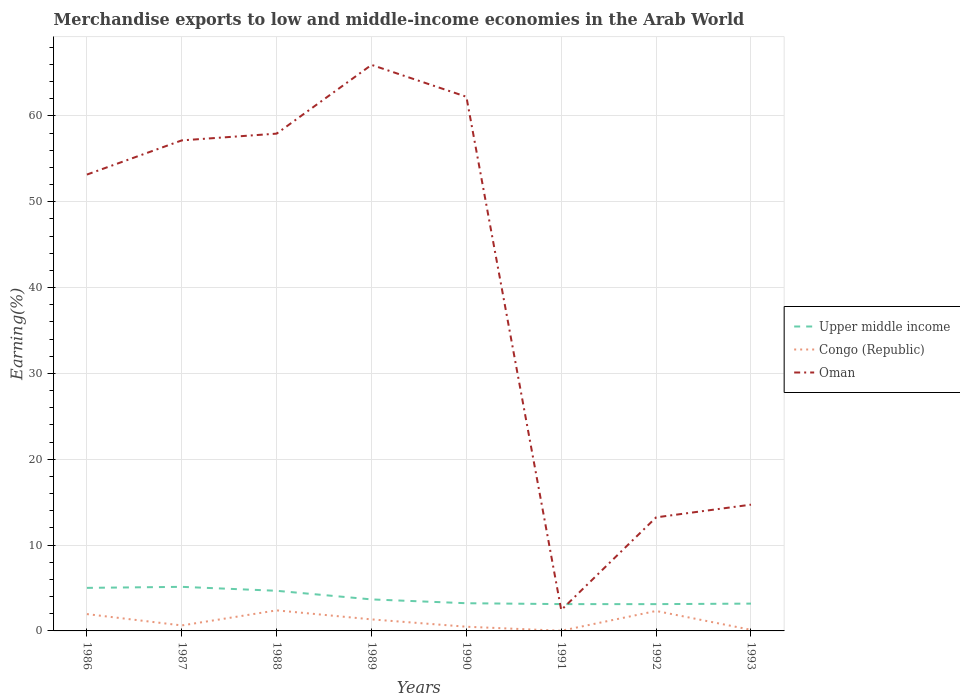How many different coloured lines are there?
Make the answer very short. 3. Is the number of lines equal to the number of legend labels?
Keep it short and to the point. Yes. Across all years, what is the maximum percentage of amount earned from merchandise exports in Oman?
Your answer should be very brief. 2.43. In which year was the percentage of amount earned from merchandise exports in Congo (Republic) maximum?
Your answer should be very brief. 1991. What is the total percentage of amount earned from merchandise exports in Upper middle income in the graph?
Your answer should be compact. 1.95. What is the difference between the highest and the second highest percentage of amount earned from merchandise exports in Upper middle income?
Provide a short and direct response. 2.01. What is the difference between the highest and the lowest percentage of amount earned from merchandise exports in Upper middle income?
Give a very brief answer. 3. Is the percentage of amount earned from merchandise exports in Oman strictly greater than the percentage of amount earned from merchandise exports in Congo (Republic) over the years?
Your response must be concise. No. What is the difference between two consecutive major ticks on the Y-axis?
Your answer should be very brief. 10. Does the graph contain any zero values?
Offer a terse response. No. Where does the legend appear in the graph?
Offer a very short reply. Center right. What is the title of the graph?
Make the answer very short. Merchandise exports to low and middle-income economies in the Arab World. What is the label or title of the X-axis?
Your answer should be compact. Years. What is the label or title of the Y-axis?
Provide a succinct answer. Earning(%). What is the Earning(%) in Upper middle income in 1986?
Offer a terse response. 5.01. What is the Earning(%) in Congo (Republic) in 1986?
Give a very brief answer. 1.96. What is the Earning(%) in Oman in 1986?
Your answer should be very brief. 53.16. What is the Earning(%) in Upper middle income in 1987?
Offer a terse response. 5.13. What is the Earning(%) of Congo (Republic) in 1987?
Offer a very short reply. 0.64. What is the Earning(%) of Oman in 1987?
Make the answer very short. 57.14. What is the Earning(%) of Upper middle income in 1988?
Give a very brief answer. 4.67. What is the Earning(%) of Congo (Republic) in 1988?
Your answer should be very brief. 2.39. What is the Earning(%) in Oman in 1988?
Provide a succinct answer. 57.93. What is the Earning(%) in Upper middle income in 1989?
Give a very brief answer. 3.67. What is the Earning(%) in Congo (Republic) in 1989?
Your response must be concise. 1.34. What is the Earning(%) in Oman in 1989?
Provide a short and direct response. 65.94. What is the Earning(%) in Upper middle income in 1990?
Ensure brevity in your answer.  3.23. What is the Earning(%) of Congo (Republic) in 1990?
Give a very brief answer. 0.49. What is the Earning(%) in Oman in 1990?
Your answer should be compact. 62.22. What is the Earning(%) of Upper middle income in 1991?
Your answer should be very brief. 3.12. What is the Earning(%) in Congo (Republic) in 1991?
Make the answer very short. 0.02. What is the Earning(%) of Oman in 1991?
Offer a very short reply. 2.43. What is the Earning(%) of Upper middle income in 1992?
Your answer should be compact. 3.12. What is the Earning(%) of Congo (Republic) in 1992?
Offer a terse response. 2.32. What is the Earning(%) in Oman in 1992?
Provide a short and direct response. 13.23. What is the Earning(%) of Upper middle income in 1993?
Provide a short and direct response. 3.18. What is the Earning(%) of Congo (Republic) in 1993?
Ensure brevity in your answer.  0.13. What is the Earning(%) of Oman in 1993?
Make the answer very short. 14.71. Across all years, what is the maximum Earning(%) in Upper middle income?
Your response must be concise. 5.13. Across all years, what is the maximum Earning(%) in Congo (Republic)?
Your response must be concise. 2.39. Across all years, what is the maximum Earning(%) of Oman?
Your answer should be very brief. 65.94. Across all years, what is the minimum Earning(%) of Upper middle income?
Your answer should be very brief. 3.12. Across all years, what is the minimum Earning(%) in Congo (Republic)?
Your answer should be compact. 0.02. Across all years, what is the minimum Earning(%) in Oman?
Your answer should be very brief. 2.43. What is the total Earning(%) of Upper middle income in the graph?
Make the answer very short. 31.15. What is the total Earning(%) of Congo (Republic) in the graph?
Your answer should be very brief. 9.3. What is the total Earning(%) in Oman in the graph?
Offer a very short reply. 326.75. What is the difference between the Earning(%) in Upper middle income in 1986 and that in 1987?
Provide a succinct answer. -0.12. What is the difference between the Earning(%) of Congo (Republic) in 1986 and that in 1987?
Ensure brevity in your answer.  1.32. What is the difference between the Earning(%) of Oman in 1986 and that in 1987?
Your response must be concise. -3.98. What is the difference between the Earning(%) in Upper middle income in 1986 and that in 1988?
Ensure brevity in your answer.  0.34. What is the difference between the Earning(%) of Congo (Republic) in 1986 and that in 1988?
Your answer should be very brief. -0.43. What is the difference between the Earning(%) in Oman in 1986 and that in 1988?
Offer a terse response. -4.77. What is the difference between the Earning(%) of Upper middle income in 1986 and that in 1989?
Keep it short and to the point. 1.34. What is the difference between the Earning(%) in Congo (Republic) in 1986 and that in 1989?
Your answer should be very brief. 0.62. What is the difference between the Earning(%) in Oman in 1986 and that in 1989?
Make the answer very short. -12.78. What is the difference between the Earning(%) in Upper middle income in 1986 and that in 1990?
Keep it short and to the point. 1.79. What is the difference between the Earning(%) in Congo (Republic) in 1986 and that in 1990?
Offer a terse response. 1.47. What is the difference between the Earning(%) of Oman in 1986 and that in 1990?
Ensure brevity in your answer.  -9.06. What is the difference between the Earning(%) in Upper middle income in 1986 and that in 1991?
Offer a terse response. 1.89. What is the difference between the Earning(%) of Congo (Republic) in 1986 and that in 1991?
Keep it short and to the point. 1.94. What is the difference between the Earning(%) in Oman in 1986 and that in 1991?
Provide a short and direct response. 50.72. What is the difference between the Earning(%) in Upper middle income in 1986 and that in 1992?
Offer a very short reply. 1.89. What is the difference between the Earning(%) of Congo (Republic) in 1986 and that in 1992?
Give a very brief answer. -0.36. What is the difference between the Earning(%) in Oman in 1986 and that in 1992?
Offer a very short reply. 39.93. What is the difference between the Earning(%) of Upper middle income in 1986 and that in 1993?
Give a very brief answer. 1.83. What is the difference between the Earning(%) of Congo (Republic) in 1986 and that in 1993?
Give a very brief answer. 1.83. What is the difference between the Earning(%) of Oman in 1986 and that in 1993?
Offer a very short reply. 38.45. What is the difference between the Earning(%) of Upper middle income in 1987 and that in 1988?
Offer a very short reply. 0.46. What is the difference between the Earning(%) in Congo (Republic) in 1987 and that in 1988?
Keep it short and to the point. -1.76. What is the difference between the Earning(%) in Oman in 1987 and that in 1988?
Offer a terse response. -0.79. What is the difference between the Earning(%) in Upper middle income in 1987 and that in 1989?
Provide a short and direct response. 1.46. What is the difference between the Earning(%) of Congo (Republic) in 1987 and that in 1989?
Offer a terse response. -0.7. What is the difference between the Earning(%) of Oman in 1987 and that in 1989?
Offer a terse response. -8.8. What is the difference between the Earning(%) in Upper middle income in 1987 and that in 1990?
Make the answer very short. 1.91. What is the difference between the Earning(%) in Congo (Republic) in 1987 and that in 1990?
Keep it short and to the point. 0.15. What is the difference between the Earning(%) of Oman in 1987 and that in 1990?
Your answer should be very brief. -5.08. What is the difference between the Earning(%) in Upper middle income in 1987 and that in 1991?
Your response must be concise. 2.01. What is the difference between the Earning(%) in Congo (Republic) in 1987 and that in 1991?
Your answer should be compact. 0.62. What is the difference between the Earning(%) of Oman in 1987 and that in 1991?
Give a very brief answer. 54.71. What is the difference between the Earning(%) of Upper middle income in 1987 and that in 1992?
Offer a very short reply. 2.01. What is the difference between the Earning(%) of Congo (Republic) in 1987 and that in 1992?
Provide a succinct answer. -1.69. What is the difference between the Earning(%) in Oman in 1987 and that in 1992?
Keep it short and to the point. 43.91. What is the difference between the Earning(%) of Upper middle income in 1987 and that in 1993?
Give a very brief answer. 1.95. What is the difference between the Earning(%) in Congo (Republic) in 1987 and that in 1993?
Ensure brevity in your answer.  0.51. What is the difference between the Earning(%) of Oman in 1987 and that in 1993?
Keep it short and to the point. 42.43. What is the difference between the Earning(%) of Upper middle income in 1988 and that in 1989?
Provide a short and direct response. 1. What is the difference between the Earning(%) in Congo (Republic) in 1988 and that in 1989?
Keep it short and to the point. 1.05. What is the difference between the Earning(%) in Oman in 1988 and that in 1989?
Your response must be concise. -8.01. What is the difference between the Earning(%) in Upper middle income in 1988 and that in 1990?
Give a very brief answer. 1.45. What is the difference between the Earning(%) in Congo (Republic) in 1988 and that in 1990?
Your answer should be compact. 1.91. What is the difference between the Earning(%) of Oman in 1988 and that in 1990?
Your answer should be compact. -4.29. What is the difference between the Earning(%) in Upper middle income in 1988 and that in 1991?
Offer a terse response. 1.55. What is the difference between the Earning(%) of Congo (Republic) in 1988 and that in 1991?
Provide a succinct answer. 2.38. What is the difference between the Earning(%) of Oman in 1988 and that in 1991?
Keep it short and to the point. 55.49. What is the difference between the Earning(%) of Upper middle income in 1988 and that in 1992?
Ensure brevity in your answer.  1.55. What is the difference between the Earning(%) of Congo (Republic) in 1988 and that in 1992?
Provide a short and direct response. 0.07. What is the difference between the Earning(%) in Oman in 1988 and that in 1992?
Make the answer very short. 44.7. What is the difference between the Earning(%) in Upper middle income in 1988 and that in 1993?
Your response must be concise. 1.49. What is the difference between the Earning(%) in Congo (Republic) in 1988 and that in 1993?
Provide a succinct answer. 2.27. What is the difference between the Earning(%) of Oman in 1988 and that in 1993?
Your answer should be compact. 43.22. What is the difference between the Earning(%) in Upper middle income in 1989 and that in 1990?
Provide a succinct answer. 0.45. What is the difference between the Earning(%) of Congo (Republic) in 1989 and that in 1990?
Offer a very short reply. 0.85. What is the difference between the Earning(%) of Oman in 1989 and that in 1990?
Provide a short and direct response. 3.71. What is the difference between the Earning(%) of Upper middle income in 1989 and that in 1991?
Your response must be concise. 0.55. What is the difference between the Earning(%) in Congo (Republic) in 1989 and that in 1991?
Give a very brief answer. 1.32. What is the difference between the Earning(%) in Oman in 1989 and that in 1991?
Keep it short and to the point. 63.5. What is the difference between the Earning(%) of Upper middle income in 1989 and that in 1992?
Offer a terse response. 0.55. What is the difference between the Earning(%) of Congo (Republic) in 1989 and that in 1992?
Your answer should be compact. -0.98. What is the difference between the Earning(%) of Oman in 1989 and that in 1992?
Your answer should be very brief. 52.71. What is the difference between the Earning(%) in Upper middle income in 1989 and that in 1993?
Your response must be concise. 0.49. What is the difference between the Earning(%) of Congo (Republic) in 1989 and that in 1993?
Offer a terse response. 1.22. What is the difference between the Earning(%) in Oman in 1989 and that in 1993?
Keep it short and to the point. 51.23. What is the difference between the Earning(%) in Upper middle income in 1990 and that in 1991?
Your answer should be very brief. 0.1. What is the difference between the Earning(%) of Congo (Republic) in 1990 and that in 1991?
Offer a very short reply. 0.47. What is the difference between the Earning(%) of Oman in 1990 and that in 1991?
Keep it short and to the point. 59.79. What is the difference between the Earning(%) of Upper middle income in 1990 and that in 1992?
Your answer should be compact. 0.11. What is the difference between the Earning(%) in Congo (Republic) in 1990 and that in 1992?
Offer a terse response. -1.84. What is the difference between the Earning(%) in Oman in 1990 and that in 1992?
Your response must be concise. 49. What is the difference between the Earning(%) of Upper middle income in 1990 and that in 1993?
Ensure brevity in your answer.  0.05. What is the difference between the Earning(%) of Congo (Republic) in 1990 and that in 1993?
Offer a very short reply. 0.36. What is the difference between the Earning(%) of Oman in 1990 and that in 1993?
Give a very brief answer. 47.51. What is the difference between the Earning(%) of Upper middle income in 1991 and that in 1992?
Your answer should be compact. 0. What is the difference between the Earning(%) in Congo (Republic) in 1991 and that in 1992?
Give a very brief answer. -2.31. What is the difference between the Earning(%) in Oman in 1991 and that in 1992?
Your answer should be compact. -10.79. What is the difference between the Earning(%) in Upper middle income in 1991 and that in 1993?
Your answer should be compact. -0.06. What is the difference between the Earning(%) of Congo (Republic) in 1991 and that in 1993?
Your response must be concise. -0.11. What is the difference between the Earning(%) in Oman in 1991 and that in 1993?
Provide a succinct answer. -12.27. What is the difference between the Earning(%) in Upper middle income in 1992 and that in 1993?
Offer a terse response. -0.06. What is the difference between the Earning(%) in Congo (Republic) in 1992 and that in 1993?
Ensure brevity in your answer.  2.2. What is the difference between the Earning(%) of Oman in 1992 and that in 1993?
Offer a very short reply. -1.48. What is the difference between the Earning(%) in Upper middle income in 1986 and the Earning(%) in Congo (Republic) in 1987?
Ensure brevity in your answer.  4.38. What is the difference between the Earning(%) in Upper middle income in 1986 and the Earning(%) in Oman in 1987?
Offer a very short reply. -52.13. What is the difference between the Earning(%) in Congo (Republic) in 1986 and the Earning(%) in Oman in 1987?
Give a very brief answer. -55.18. What is the difference between the Earning(%) of Upper middle income in 1986 and the Earning(%) of Congo (Republic) in 1988?
Ensure brevity in your answer.  2.62. What is the difference between the Earning(%) of Upper middle income in 1986 and the Earning(%) of Oman in 1988?
Give a very brief answer. -52.91. What is the difference between the Earning(%) in Congo (Republic) in 1986 and the Earning(%) in Oman in 1988?
Your answer should be very brief. -55.97. What is the difference between the Earning(%) in Upper middle income in 1986 and the Earning(%) in Congo (Republic) in 1989?
Provide a succinct answer. 3.67. What is the difference between the Earning(%) in Upper middle income in 1986 and the Earning(%) in Oman in 1989?
Your response must be concise. -60.92. What is the difference between the Earning(%) of Congo (Republic) in 1986 and the Earning(%) of Oman in 1989?
Offer a very short reply. -63.98. What is the difference between the Earning(%) of Upper middle income in 1986 and the Earning(%) of Congo (Republic) in 1990?
Offer a terse response. 4.53. What is the difference between the Earning(%) of Upper middle income in 1986 and the Earning(%) of Oman in 1990?
Provide a short and direct response. -57.21. What is the difference between the Earning(%) in Congo (Republic) in 1986 and the Earning(%) in Oman in 1990?
Your answer should be very brief. -60.26. What is the difference between the Earning(%) in Upper middle income in 1986 and the Earning(%) in Congo (Republic) in 1991?
Give a very brief answer. 5. What is the difference between the Earning(%) of Upper middle income in 1986 and the Earning(%) of Oman in 1991?
Make the answer very short. 2.58. What is the difference between the Earning(%) of Congo (Republic) in 1986 and the Earning(%) of Oman in 1991?
Give a very brief answer. -0.47. What is the difference between the Earning(%) of Upper middle income in 1986 and the Earning(%) of Congo (Republic) in 1992?
Give a very brief answer. 2.69. What is the difference between the Earning(%) of Upper middle income in 1986 and the Earning(%) of Oman in 1992?
Your response must be concise. -8.21. What is the difference between the Earning(%) of Congo (Republic) in 1986 and the Earning(%) of Oman in 1992?
Offer a terse response. -11.27. What is the difference between the Earning(%) of Upper middle income in 1986 and the Earning(%) of Congo (Republic) in 1993?
Provide a short and direct response. 4.89. What is the difference between the Earning(%) of Upper middle income in 1986 and the Earning(%) of Oman in 1993?
Your answer should be very brief. -9.69. What is the difference between the Earning(%) in Congo (Republic) in 1986 and the Earning(%) in Oman in 1993?
Give a very brief answer. -12.75. What is the difference between the Earning(%) in Upper middle income in 1987 and the Earning(%) in Congo (Republic) in 1988?
Give a very brief answer. 2.74. What is the difference between the Earning(%) of Upper middle income in 1987 and the Earning(%) of Oman in 1988?
Your answer should be very brief. -52.79. What is the difference between the Earning(%) of Congo (Republic) in 1987 and the Earning(%) of Oman in 1988?
Keep it short and to the point. -57.29. What is the difference between the Earning(%) of Upper middle income in 1987 and the Earning(%) of Congo (Republic) in 1989?
Give a very brief answer. 3.79. What is the difference between the Earning(%) in Upper middle income in 1987 and the Earning(%) in Oman in 1989?
Provide a short and direct response. -60.8. What is the difference between the Earning(%) of Congo (Republic) in 1987 and the Earning(%) of Oman in 1989?
Keep it short and to the point. -65.3. What is the difference between the Earning(%) of Upper middle income in 1987 and the Earning(%) of Congo (Republic) in 1990?
Provide a short and direct response. 4.65. What is the difference between the Earning(%) of Upper middle income in 1987 and the Earning(%) of Oman in 1990?
Your answer should be compact. -57.09. What is the difference between the Earning(%) of Congo (Republic) in 1987 and the Earning(%) of Oman in 1990?
Your answer should be compact. -61.58. What is the difference between the Earning(%) in Upper middle income in 1987 and the Earning(%) in Congo (Republic) in 1991?
Offer a terse response. 5.12. What is the difference between the Earning(%) in Upper middle income in 1987 and the Earning(%) in Oman in 1991?
Give a very brief answer. 2.7. What is the difference between the Earning(%) in Congo (Republic) in 1987 and the Earning(%) in Oman in 1991?
Your answer should be compact. -1.79. What is the difference between the Earning(%) in Upper middle income in 1987 and the Earning(%) in Congo (Republic) in 1992?
Ensure brevity in your answer.  2.81. What is the difference between the Earning(%) in Upper middle income in 1987 and the Earning(%) in Oman in 1992?
Your answer should be very brief. -8.09. What is the difference between the Earning(%) of Congo (Republic) in 1987 and the Earning(%) of Oman in 1992?
Offer a very short reply. -12.59. What is the difference between the Earning(%) of Upper middle income in 1987 and the Earning(%) of Congo (Republic) in 1993?
Give a very brief answer. 5.01. What is the difference between the Earning(%) of Upper middle income in 1987 and the Earning(%) of Oman in 1993?
Your response must be concise. -9.57. What is the difference between the Earning(%) of Congo (Republic) in 1987 and the Earning(%) of Oman in 1993?
Provide a short and direct response. -14.07. What is the difference between the Earning(%) of Upper middle income in 1988 and the Earning(%) of Congo (Republic) in 1989?
Offer a terse response. 3.33. What is the difference between the Earning(%) of Upper middle income in 1988 and the Earning(%) of Oman in 1989?
Your answer should be compact. -61.26. What is the difference between the Earning(%) of Congo (Republic) in 1988 and the Earning(%) of Oman in 1989?
Provide a short and direct response. -63.54. What is the difference between the Earning(%) in Upper middle income in 1988 and the Earning(%) in Congo (Republic) in 1990?
Offer a very short reply. 4.19. What is the difference between the Earning(%) in Upper middle income in 1988 and the Earning(%) in Oman in 1990?
Your answer should be compact. -57.55. What is the difference between the Earning(%) in Congo (Republic) in 1988 and the Earning(%) in Oman in 1990?
Your answer should be very brief. -59.83. What is the difference between the Earning(%) in Upper middle income in 1988 and the Earning(%) in Congo (Republic) in 1991?
Provide a succinct answer. 4.66. What is the difference between the Earning(%) of Upper middle income in 1988 and the Earning(%) of Oman in 1991?
Keep it short and to the point. 2.24. What is the difference between the Earning(%) of Congo (Republic) in 1988 and the Earning(%) of Oman in 1991?
Provide a succinct answer. -0.04. What is the difference between the Earning(%) in Upper middle income in 1988 and the Earning(%) in Congo (Republic) in 1992?
Your response must be concise. 2.35. What is the difference between the Earning(%) of Upper middle income in 1988 and the Earning(%) of Oman in 1992?
Give a very brief answer. -8.55. What is the difference between the Earning(%) in Congo (Republic) in 1988 and the Earning(%) in Oman in 1992?
Make the answer very short. -10.83. What is the difference between the Earning(%) of Upper middle income in 1988 and the Earning(%) of Congo (Republic) in 1993?
Give a very brief answer. 4.55. What is the difference between the Earning(%) of Upper middle income in 1988 and the Earning(%) of Oman in 1993?
Your answer should be very brief. -10.03. What is the difference between the Earning(%) of Congo (Republic) in 1988 and the Earning(%) of Oman in 1993?
Offer a terse response. -12.31. What is the difference between the Earning(%) of Upper middle income in 1989 and the Earning(%) of Congo (Republic) in 1990?
Offer a terse response. 3.18. What is the difference between the Earning(%) in Upper middle income in 1989 and the Earning(%) in Oman in 1990?
Keep it short and to the point. -58.55. What is the difference between the Earning(%) of Congo (Republic) in 1989 and the Earning(%) of Oman in 1990?
Your response must be concise. -60.88. What is the difference between the Earning(%) of Upper middle income in 1989 and the Earning(%) of Congo (Republic) in 1991?
Your answer should be very brief. 3.65. What is the difference between the Earning(%) of Upper middle income in 1989 and the Earning(%) of Oman in 1991?
Provide a succinct answer. 1.24. What is the difference between the Earning(%) in Congo (Republic) in 1989 and the Earning(%) in Oman in 1991?
Offer a very short reply. -1.09. What is the difference between the Earning(%) in Upper middle income in 1989 and the Earning(%) in Congo (Republic) in 1992?
Give a very brief answer. 1.35. What is the difference between the Earning(%) in Upper middle income in 1989 and the Earning(%) in Oman in 1992?
Your answer should be very brief. -9.56. What is the difference between the Earning(%) of Congo (Republic) in 1989 and the Earning(%) of Oman in 1992?
Your response must be concise. -11.88. What is the difference between the Earning(%) of Upper middle income in 1989 and the Earning(%) of Congo (Republic) in 1993?
Keep it short and to the point. 3.54. What is the difference between the Earning(%) of Upper middle income in 1989 and the Earning(%) of Oman in 1993?
Provide a succinct answer. -11.04. What is the difference between the Earning(%) of Congo (Republic) in 1989 and the Earning(%) of Oman in 1993?
Make the answer very short. -13.36. What is the difference between the Earning(%) in Upper middle income in 1990 and the Earning(%) in Congo (Republic) in 1991?
Make the answer very short. 3.21. What is the difference between the Earning(%) of Upper middle income in 1990 and the Earning(%) of Oman in 1991?
Your response must be concise. 0.79. What is the difference between the Earning(%) in Congo (Republic) in 1990 and the Earning(%) in Oman in 1991?
Your response must be concise. -1.94. What is the difference between the Earning(%) in Upper middle income in 1990 and the Earning(%) in Congo (Republic) in 1992?
Keep it short and to the point. 0.9. What is the difference between the Earning(%) of Upper middle income in 1990 and the Earning(%) of Oman in 1992?
Give a very brief answer. -10. What is the difference between the Earning(%) in Congo (Republic) in 1990 and the Earning(%) in Oman in 1992?
Ensure brevity in your answer.  -12.74. What is the difference between the Earning(%) of Upper middle income in 1990 and the Earning(%) of Congo (Republic) in 1993?
Your response must be concise. 3.1. What is the difference between the Earning(%) of Upper middle income in 1990 and the Earning(%) of Oman in 1993?
Make the answer very short. -11.48. What is the difference between the Earning(%) of Congo (Republic) in 1990 and the Earning(%) of Oman in 1993?
Keep it short and to the point. -14.22. What is the difference between the Earning(%) of Upper middle income in 1991 and the Earning(%) of Congo (Republic) in 1992?
Provide a succinct answer. 0.8. What is the difference between the Earning(%) in Upper middle income in 1991 and the Earning(%) in Oman in 1992?
Your response must be concise. -10.1. What is the difference between the Earning(%) in Congo (Republic) in 1991 and the Earning(%) in Oman in 1992?
Offer a terse response. -13.21. What is the difference between the Earning(%) in Upper middle income in 1991 and the Earning(%) in Congo (Republic) in 1993?
Make the answer very short. 3. What is the difference between the Earning(%) of Upper middle income in 1991 and the Earning(%) of Oman in 1993?
Give a very brief answer. -11.58. What is the difference between the Earning(%) of Congo (Republic) in 1991 and the Earning(%) of Oman in 1993?
Your response must be concise. -14.69. What is the difference between the Earning(%) of Upper middle income in 1992 and the Earning(%) of Congo (Republic) in 1993?
Provide a succinct answer. 2.99. What is the difference between the Earning(%) of Upper middle income in 1992 and the Earning(%) of Oman in 1993?
Offer a very short reply. -11.59. What is the difference between the Earning(%) in Congo (Republic) in 1992 and the Earning(%) in Oman in 1993?
Provide a short and direct response. -12.38. What is the average Earning(%) in Upper middle income per year?
Your answer should be very brief. 3.89. What is the average Earning(%) in Congo (Republic) per year?
Give a very brief answer. 1.16. What is the average Earning(%) of Oman per year?
Ensure brevity in your answer.  40.84. In the year 1986, what is the difference between the Earning(%) in Upper middle income and Earning(%) in Congo (Republic)?
Give a very brief answer. 3.05. In the year 1986, what is the difference between the Earning(%) of Upper middle income and Earning(%) of Oman?
Your answer should be compact. -48.14. In the year 1986, what is the difference between the Earning(%) of Congo (Republic) and Earning(%) of Oman?
Give a very brief answer. -51.2. In the year 1987, what is the difference between the Earning(%) of Upper middle income and Earning(%) of Congo (Republic)?
Your answer should be very brief. 4.5. In the year 1987, what is the difference between the Earning(%) in Upper middle income and Earning(%) in Oman?
Give a very brief answer. -52.01. In the year 1987, what is the difference between the Earning(%) of Congo (Republic) and Earning(%) of Oman?
Provide a succinct answer. -56.5. In the year 1988, what is the difference between the Earning(%) in Upper middle income and Earning(%) in Congo (Republic)?
Your answer should be very brief. 2.28. In the year 1988, what is the difference between the Earning(%) in Upper middle income and Earning(%) in Oman?
Offer a terse response. -53.25. In the year 1988, what is the difference between the Earning(%) of Congo (Republic) and Earning(%) of Oman?
Your answer should be very brief. -55.53. In the year 1989, what is the difference between the Earning(%) of Upper middle income and Earning(%) of Congo (Republic)?
Make the answer very short. 2.33. In the year 1989, what is the difference between the Earning(%) of Upper middle income and Earning(%) of Oman?
Make the answer very short. -62.27. In the year 1989, what is the difference between the Earning(%) of Congo (Republic) and Earning(%) of Oman?
Offer a very short reply. -64.59. In the year 1990, what is the difference between the Earning(%) of Upper middle income and Earning(%) of Congo (Republic)?
Your answer should be compact. 2.74. In the year 1990, what is the difference between the Earning(%) of Upper middle income and Earning(%) of Oman?
Provide a succinct answer. -59. In the year 1990, what is the difference between the Earning(%) of Congo (Republic) and Earning(%) of Oman?
Offer a very short reply. -61.73. In the year 1991, what is the difference between the Earning(%) in Upper middle income and Earning(%) in Congo (Republic)?
Ensure brevity in your answer.  3.1. In the year 1991, what is the difference between the Earning(%) in Upper middle income and Earning(%) in Oman?
Keep it short and to the point. 0.69. In the year 1991, what is the difference between the Earning(%) of Congo (Republic) and Earning(%) of Oman?
Offer a very short reply. -2.41. In the year 1992, what is the difference between the Earning(%) in Upper middle income and Earning(%) in Congo (Republic)?
Your answer should be compact. 0.8. In the year 1992, what is the difference between the Earning(%) in Upper middle income and Earning(%) in Oman?
Make the answer very short. -10.11. In the year 1992, what is the difference between the Earning(%) in Congo (Republic) and Earning(%) in Oman?
Offer a terse response. -10.9. In the year 1993, what is the difference between the Earning(%) in Upper middle income and Earning(%) in Congo (Republic)?
Offer a very short reply. 3.05. In the year 1993, what is the difference between the Earning(%) in Upper middle income and Earning(%) in Oman?
Offer a terse response. -11.53. In the year 1993, what is the difference between the Earning(%) of Congo (Republic) and Earning(%) of Oman?
Your response must be concise. -14.58. What is the ratio of the Earning(%) of Upper middle income in 1986 to that in 1987?
Your answer should be compact. 0.98. What is the ratio of the Earning(%) in Congo (Republic) in 1986 to that in 1987?
Ensure brevity in your answer.  3.07. What is the ratio of the Earning(%) of Oman in 1986 to that in 1987?
Give a very brief answer. 0.93. What is the ratio of the Earning(%) in Upper middle income in 1986 to that in 1988?
Provide a succinct answer. 1.07. What is the ratio of the Earning(%) in Congo (Republic) in 1986 to that in 1988?
Offer a very short reply. 0.82. What is the ratio of the Earning(%) in Oman in 1986 to that in 1988?
Your answer should be compact. 0.92. What is the ratio of the Earning(%) of Upper middle income in 1986 to that in 1989?
Offer a terse response. 1.37. What is the ratio of the Earning(%) of Congo (Republic) in 1986 to that in 1989?
Ensure brevity in your answer.  1.46. What is the ratio of the Earning(%) of Oman in 1986 to that in 1989?
Offer a terse response. 0.81. What is the ratio of the Earning(%) of Upper middle income in 1986 to that in 1990?
Ensure brevity in your answer.  1.55. What is the ratio of the Earning(%) of Congo (Republic) in 1986 to that in 1990?
Your answer should be compact. 4.01. What is the ratio of the Earning(%) in Oman in 1986 to that in 1990?
Give a very brief answer. 0.85. What is the ratio of the Earning(%) in Upper middle income in 1986 to that in 1991?
Your response must be concise. 1.61. What is the ratio of the Earning(%) of Congo (Republic) in 1986 to that in 1991?
Ensure brevity in your answer.  102.05. What is the ratio of the Earning(%) of Oman in 1986 to that in 1991?
Offer a very short reply. 21.84. What is the ratio of the Earning(%) of Upper middle income in 1986 to that in 1992?
Offer a very short reply. 1.61. What is the ratio of the Earning(%) in Congo (Republic) in 1986 to that in 1992?
Make the answer very short. 0.84. What is the ratio of the Earning(%) of Oman in 1986 to that in 1992?
Keep it short and to the point. 4.02. What is the ratio of the Earning(%) in Upper middle income in 1986 to that in 1993?
Keep it short and to the point. 1.58. What is the ratio of the Earning(%) in Congo (Republic) in 1986 to that in 1993?
Your answer should be very brief. 15.24. What is the ratio of the Earning(%) of Oman in 1986 to that in 1993?
Provide a succinct answer. 3.61. What is the ratio of the Earning(%) of Upper middle income in 1987 to that in 1988?
Provide a short and direct response. 1.1. What is the ratio of the Earning(%) in Congo (Republic) in 1987 to that in 1988?
Offer a very short reply. 0.27. What is the ratio of the Earning(%) of Oman in 1987 to that in 1988?
Offer a very short reply. 0.99. What is the ratio of the Earning(%) of Upper middle income in 1987 to that in 1989?
Your response must be concise. 1.4. What is the ratio of the Earning(%) of Congo (Republic) in 1987 to that in 1989?
Give a very brief answer. 0.48. What is the ratio of the Earning(%) of Oman in 1987 to that in 1989?
Provide a succinct answer. 0.87. What is the ratio of the Earning(%) of Upper middle income in 1987 to that in 1990?
Offer a very short reply. 1.59. What is the ratio of the Earning(%) of Congo (Republic) in 1987 to that in 1990?
Give a very brief answer. 1.31. What is the ratio of the Earning(%) in Oman in 1987 to that in 1990?
Make the answer very short. 0.92. What is the ratio of the Earning(%) in Upper middle income in 1987 to that in 1991?
Keep it short and to the point. 1.64. What is the ratio of the Earning(%) of Congo (Republic) in 1987 to that in 1991?
Offer a very short reply. 33.28. What is the ratio of the Earning(%) in Oman in 1987 to that in 1991?
Ensure brevity in your answer.  23.48. What is the ratio of the Earning(%) in Upper middle income in 1987 to that in 1992?
Offer a terse response. 1.65. What is the ratio of the Earning(%) of Congo (Republic) in 1987 to that in 1992?
Provide a short and direct response. 0.28. What is the ratio of the Earning(%) of Oman in 1987 to that in 1992?
Provide a succinct answer. 4.32. What is the ratio of the Earning(%) in Upper middle income in 1987 to that in 1993?
Make the answer very short. 1.61. What is the ratio of the Earning(%) of Congo (Republic) in 1987 to that in 1993?
Provide a short and direct response. 4.97. What is the ratio of the Earning(%) in Oman in 1987 to that in 1993?
Provide a short and direct response. 3.88. What is the ratio of the Earning(%) of Upper middle income in 1988 to that in 1989?
Offer a very short reply. 1.27. What is the ratio of the Earning(%) of Congo (Republic) in 1988 to that in 1989?
Keep it short and to the point. 1.78. What is the ratio of the Earning(%) of Oman in 1988 to that in 1989?
Provide a succinct answer. 0.88. What is the ratio of the Earning(%) of Upper middle income in 1988 to that in 1990?
Give a very brief answer. 1.45. What is the ratio of the Earning(%) of Congo (Republic) in 1988 to that in 1990?
Your answer should be compact. 4.9. What is the ratio of the Earning(%) of Oman in 1988 to that in 1990?
Your answer should be very brief. 0.93. What is the ratio of the Earning(%) in Upper middle income in 1988 to that in 1991?
Ensure brevity in your answer.  1.5. What is the ratio of the Earning(%) of Congo (Republic) in 1988 to that in 1991?
Provide a short and direct response. 124.63. What is the ratio of the Earning(%) in Oman in 1988 to that in 1991?
Give a very brief answer. 23.8. What is the ratio of the Earning(%) in Upper middle income in 1988 to that in 1992?
Give a very brief answer. 1.5. What is the ratio of the Earning(%) in Oman in 1988 to that in 1992?
Keep it short and to the point. 4.38. What is the ratio of the Earning(%) in Upper middle income in 1988 to that in 1993?
Ensure brevity in your answer.  1.47. What is the ratio of the Earning(%) in Congo (Republic) in 1988 to that in 1993?
Offer a terse response. 18.62. What is the ratio of the Earning(%) in Oman in 1988 to that in 1993?
Your answer should be very brief. 3.94. What is the ratio of the Earning(%) of Upper middle income in 1989 to that in 1990?
Make the answer very short. 1.14. What is the ratio of the Earning(%) of Congo (Republic) in 1989 to that in 1990?
Your response must be concise. 2.75. What is the ratio of the Earning(%) of Oman in 1989 to that in 1990?
Give a very brief answer. 1.06. What is the ratio of the Earning(%) of Upper middle income in 1989 to that in 1991?
Your answer should be compact. 1.18. What is the ratio of the Earning(%) of Congo (Republic) in 1989 to that in 1991?
Offer a very short reply. 69.96. What is the ratio of the Earning(%) in Oman in 1989 to that in 1991?
Provide a short and direct response. 27.09. What is the ratio of the Earning(%) in Upper middle income in 1989 to that in 1992?
Your answer should be compact. 1.18. What is the ratio of the Earning(%) of Congo (Republic) in 1989 to that in 1992?
Make the answer very short. 0.58. What is the ratio of the Earning(%) in Oman in 1989 to that in 1992?
Provide a succinct answer. 4.99. What is the ratio of the Earning(%) of Upper middle income in 1989 to that in 1993?
Your response must be concise. 1.15. What is the ratio of the Earning(%) of Congo (Republic) in 1989 to that in 1993?
Your answer should be very brief. 10.45. What is the ratio of the Earning(%) in Oman in 1989 to that in 1993?
Keep it short and to the point. 4.48. What is the ratio of the Earning(%) in Upper middle income in 1990 to that in 1991?
Provide a succinct answer. 1.03. What is the ratio of the Earning(%) in Congo (Republic) in 1990 to that in 1991?
Give a very brief answer. 25.45. What is the ratio of the Earning(%) of Oman in 1990 to that in 1991?
Your answer should be compact. 25.57. What is the ratio of the Earning(%) in Upper middle income in 1990 to that in 1992?
Ensure brevity in your answer.  1.03. What is the ratio of the Earning(%) in Congo (Republic) in 1990 to that in 1992?
Provide a short and direct response. 0.21. What is the ratio of the Earning(%) of Oman in 1990 to that in 1992?
Offer a terse response. 4.7. What is the ratio of the Earning(%) in Upper middle income in 1990 to that in 1993?
Your answer should be compact. 1.01. What is the ratio of the Earning(%) in Congo (Republic) in 1990 to that in 1993?
Offer a terse response. 3.8. What is the ratio of the Earning(%) in Oman in 1990 to that in 1993?
Give a very brief answer. 4.23. What is the ratio of the Earning(%) in Upper middle income in 1991 to that in 1992?
Offer a terse response. 1. What is the ratio of the Earning(%) of Congo (Republic) in 1991 to that in 1992?
Your answer should be compact. 0.01. What is the ratio of the Earning(%) in Oman in 1991 to that in 1992?
Your response must be concise. 0.18. What is the ratio of the Earning(%) of Upper middle income in 1991 to that in 1993?
Provide a succinct answer. 0.98. What is the ratio of the Earning(%) in Congo (Republic) in 1991 to that in 1993?
Provide a short and direct response. 0.15. What is the ratio of the Earning(%) of Oman in 1991 to that in 1993?
Give a very brief answer. 0.17. What is the ratio of the Earning(%) in Congo (Republic) in 1992 to that in 1993?
Keep it short and to the point. 18.08. What is the ratio of the Earning(%) of Oman in 1992 to that in 1993?
Your response must be concise. 0.9. What is the difference between the highest and the second highest Earning(%) in Upper middle income?
Give a very brief answer. 0.12. What is the difference between the highest and the second highest Earning(%) of Congo (Republic)?
Make the answer very short. 0.07. What is the difference between the highest and the second highest Earning(%) of Oman?
Offer a very short reply. 3.71. What is the difference between the highest and the lowest Earning(%) of Upper middle income?
Provide a short and direct response. 2.01. What is the difference between the highest and the lowest Earning(%) in Congo (Republic)?
Offer a terse response. 2.38. What is the difference between the highest and the lowest Earning(%) of Oman?
Ensure brevity in your answer.  63.5. 